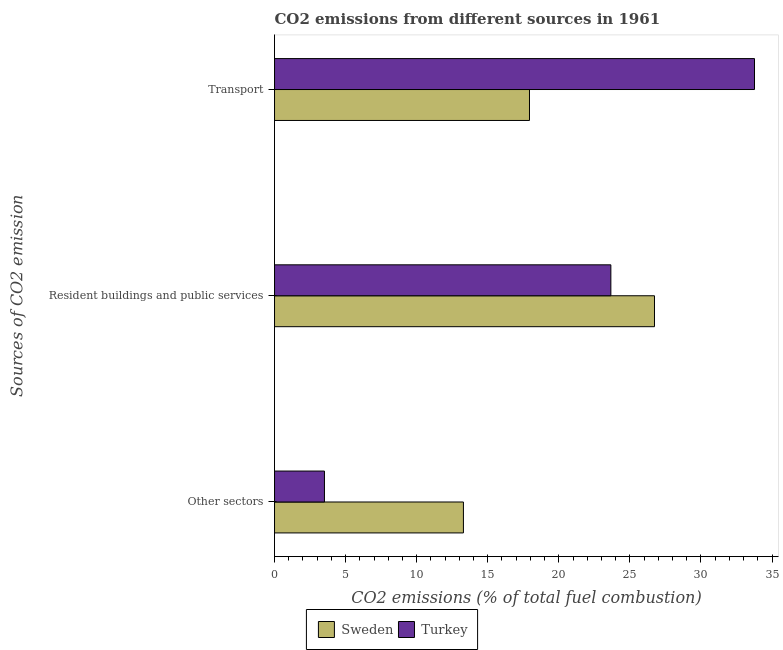How many groups of bars are there?
Your answer should be very brief. 3. How many bars are there on the 1st tick from the bottom?
Offer a terse response. 2. What is the label of the 3rd group of bars from the top?
Offer a terse response. Other sectors. What is the percentage of co2 emissions from other sectors in Sweden?
Offer a very short reply. 13.29. Across all countries, what is the maximum percentage of co2 emissions from resident buildings and public services?
Your response must be concise. 26.73. Across all countries, what is the minimum percentage of co2 emissions from other sectors?
Offer a very short reply. 3.51. What is the total percentage of co2 emissions from resident buildings and public services in the graph?
Your answer should be compact. 50.39. What is the difference between the percentage of co2 emissions from resident buildings and public services in Turkey and that in Sweden?
Provide a succinct answer. -3.07. What is the difference between the percentage of co2 emissions from transport in Sweden and the percentage of co2 emissions from resident buildings and public services in Turkey?
Provide a short and direct response. -5.72. What is the average percentage of co2 emissions from transport per country?
Your answer should be compact. 25.85. What is the difference between the percentage of co2 emissions from transport and percentage of co2 emissions from other sectors in Sweden?
Your response must be concise. 4.65. In how many countries, is the percentage of co2 emissions from transport greater than 8 %?
Your response must be concise. 2. What is the ratio of the percentage of co2 emissions from other sectors in Sweden to that in Turkey?
Your answer should be compact. 3.78. What is the difference between the highest and the second highest percentage of co2 emissions from resident buildings and public services?
Provide a succinct answer. 3.07. What is the difference between the highest and the lowest percentage of co2 emissions from transport?
Provide a succinct answer. 15.83. In how many countries, is the percentage of co2 emissions from resident buildings and public services greater than the average percentage of co2 emissions from resident buildings and public services taken over all countries?
Make the answer very short. 1. Is the sum of the percentage of co2 emissions from other sectors in Sweden and Turkey greater than the maximum percentage of co2 emissions from resident buildings and public services across all countries?
Provide a succinct answer. No. What does the 1st bar from the bottom in Resident buildings and public services represents?
Ensure brevity in your answer.  Sweden. How many bars are there?
Make the answer very short. 6. What is the difference between two consecutive major ticks on the X-axis?
Your answer should be compact. 5. Does the graph contain grids?
Keep it short and to the point. No. Where does the legend appear in the graph?
Provide a short and direct response. Bottom center. How are the legend labels stacked?
Your answer should be very brief. Horizontal. What is the title of the graph?
Your response must be concise. CO2 emissions from different sources in 1961. What is the label or title of the X-axis?
Ensure brevity in your answer.  CO2 emissions (% of total fuel combustion). What is the label or title of the Y-axis?
Your answer should be very brief. Sources of CO2 emission. What is the CO2 emissions (% of total fuel combustion) in Sweden in Other sectors?
Your answer should be very brief. 13.29. What is the CO2 emissions (% of total fuel combustion) of Turkey in Other sectors?
Your answer should be very brief. 3.51. What is the CO2 emissions (% of total fuel combustion) in Sweden in Resident buildings and public services?
Provide a short and direct response. 26.73. What is the CO2 emissions (% of total fuel combustion) of Turkey in Resident buildings and public services?
Provide a short and direct response. 23.66. What is the CO2 emissions (% of total fuel combustion) in Sweden in Transport?
Offer a very short reply. 17.94. What is the CO2 emissions (% of total fuel combustion) of Turkey in Transport?
Provide a short and direct response. 33.76. Across all Sources of CO2 emission, what is the maximum CO2 emissions (% of total fuel combustion) of Sweden?
Offer a very short reply. 26.73. Across all Sources of CO2 emission, what is the maximum CO2 emissions (% of total fuel combustion) of Turkey?
Give a very brief answer. 33.76. Across all Sources of CO2 emission, what is the minimum CO2 emissions (% of total fuel combustion) of Sweden?
Your response must be concise. 13.29. Across all Sources of CO2 emission, what is the minimum CO2 emissions (% of total fuel combustion) in Turkey?
Offer a terse response. 3.51. What is the total CO2 emissions (% of total fuel combustion) of Sweden in the graph?
Your response must be concise. 57.95. What is the total CO2 emissions (% of total fuel combustion) of Turkey in the graph?
Offer a terse response. 60.94. What is the difference between the CO2 emissions (% of total fuel combustion) of Sweden in Other sectors and that in Resident buildings and public services?
Offer a very short reply. -13.44. What is the difference between the CO2 emissions (% of total fuel combustion) of Turkey in Other sectors and that in Resident buildings and public services?
Provide a succinct answer. -20.15. What is the difference between the CO2 emissions (% of total fuel combustion) in Sweden in Other sectors and that in Transport?
Provide a short and direct response. -4.65. What is the difference between the CO2 emissions (% of total fuel combustion) of Turkey in Other sectors and that in Transport?
Provide a succinct answer. -30.25. What is the difference between the CO2 emissions (% of total fuel combustion) in Sweden in Resident buildings and public services and that in Transport?
Ensure brevity in your answer.  8.79. What is the difference between the CO2 emissions (% of total fuel combustion) of Turkey in Resident buildings and public services and that in Transport?
Your answer should be compact. -10.1. What is the difference between the CO2 emissions (% of total fuel combustion) of Sweden in Other sectors and the CO2 emissions (% of total fuel combustion) of Turkey in Resident buildings and public services?
Make the answer very short. -10.37. What is the difference between the CO2 emissions (% of total fuel combustion) in Sweden in Other sectors and the CO2 emissions (% of total fuel combustion) in Turkey in Transport?
Offer a very short reply. -20.48. What is the difference between the CO2 emissions (% of total fuel combustion) in Sweden in Resident buildings and public services and the CO2 emissions (% of total fuel combustion) in Turkey in Transport?
Provide a succinct answer. -7.04. What is the average CO2 emissions (% of total fuel combustion) of Sweden per Sources of CO2 emission?
Give a very brief answer. 19.32. What is the average CO2 emissions (% of total fuel combustion) in Turkey per Sources of CO2 emission?
Your answer should be compact. 20.31. What is the difference between the CO2 emissions (% of total fuel combustion) of Sweden and CO2 emissions (% of total fuel combustion) of Turkey in Other sectors?
Provide a short and direct response. 9.78. What is the difference between the CO2 emissions (% of total fuel combustion) of Sweden and CO2 emissions (% of total fuel combustion) of Turkey in Resident buildings and public services?
Offer a very short reply. 3.07. What is the difference between the CO2 emissions (% of total fuel combustion) in Sweden and CO2 emissions (% of total fuel combustion) in Turkey in Transport?
Make the answer very short. -15.83. What is the ratio of the CO2 emissions (% of total fuel combustion) of Sweden in Other sectors to that in Resident buildings and public services?
Offer a very short reply. 0.5. What is the ratio of the CO2 emissions (% of total fuel combustion) in Turkey in Other sectors to that in Resident buildings and public services?
Offer a very short reply. 0.15. What is the ratio of the CO2 emissions (% of total fuel combustion) in Sweden in Other sectors to that in Transport?
Keep it short and to the point. 0.74. What is the ratio of the CO2 emissions (% of total fuel combustion) in Turkey in Other sectors to that in Transport?
Keep it short and to the point. 0.1. What is the ratio of the CO2 emissions (% of total fuel combustion) of Sweden in Resident buildings and public services to that in Transport?
Offer a terse response. 1.49. What is the ratio of the CO2 emissions (% of total fuel combustion) in Turkey in Resident buildings and public services to that in Transport?
Offer a very short reply. 0.7. What is the difference between the highest and the second highest CO2 emissions (% of total fuel combustion) in Sweden?
Ensure brevity in your answer.  8.79. What is the difference between the highest and the second highest CO2 emissions (% of total fuel combustion) of Turkey?
Provide a short and direct response. 10.1. What is the difference between the highest and the lowest CO2 emissions (% of total fuel combustion) of Sweden?
Give a very brief answer. 13.44. What is the difference between the highest and the lowest CO2 emissions (% of total fuel combustion) in Turkey?
Make the answer very short. 30.25. 